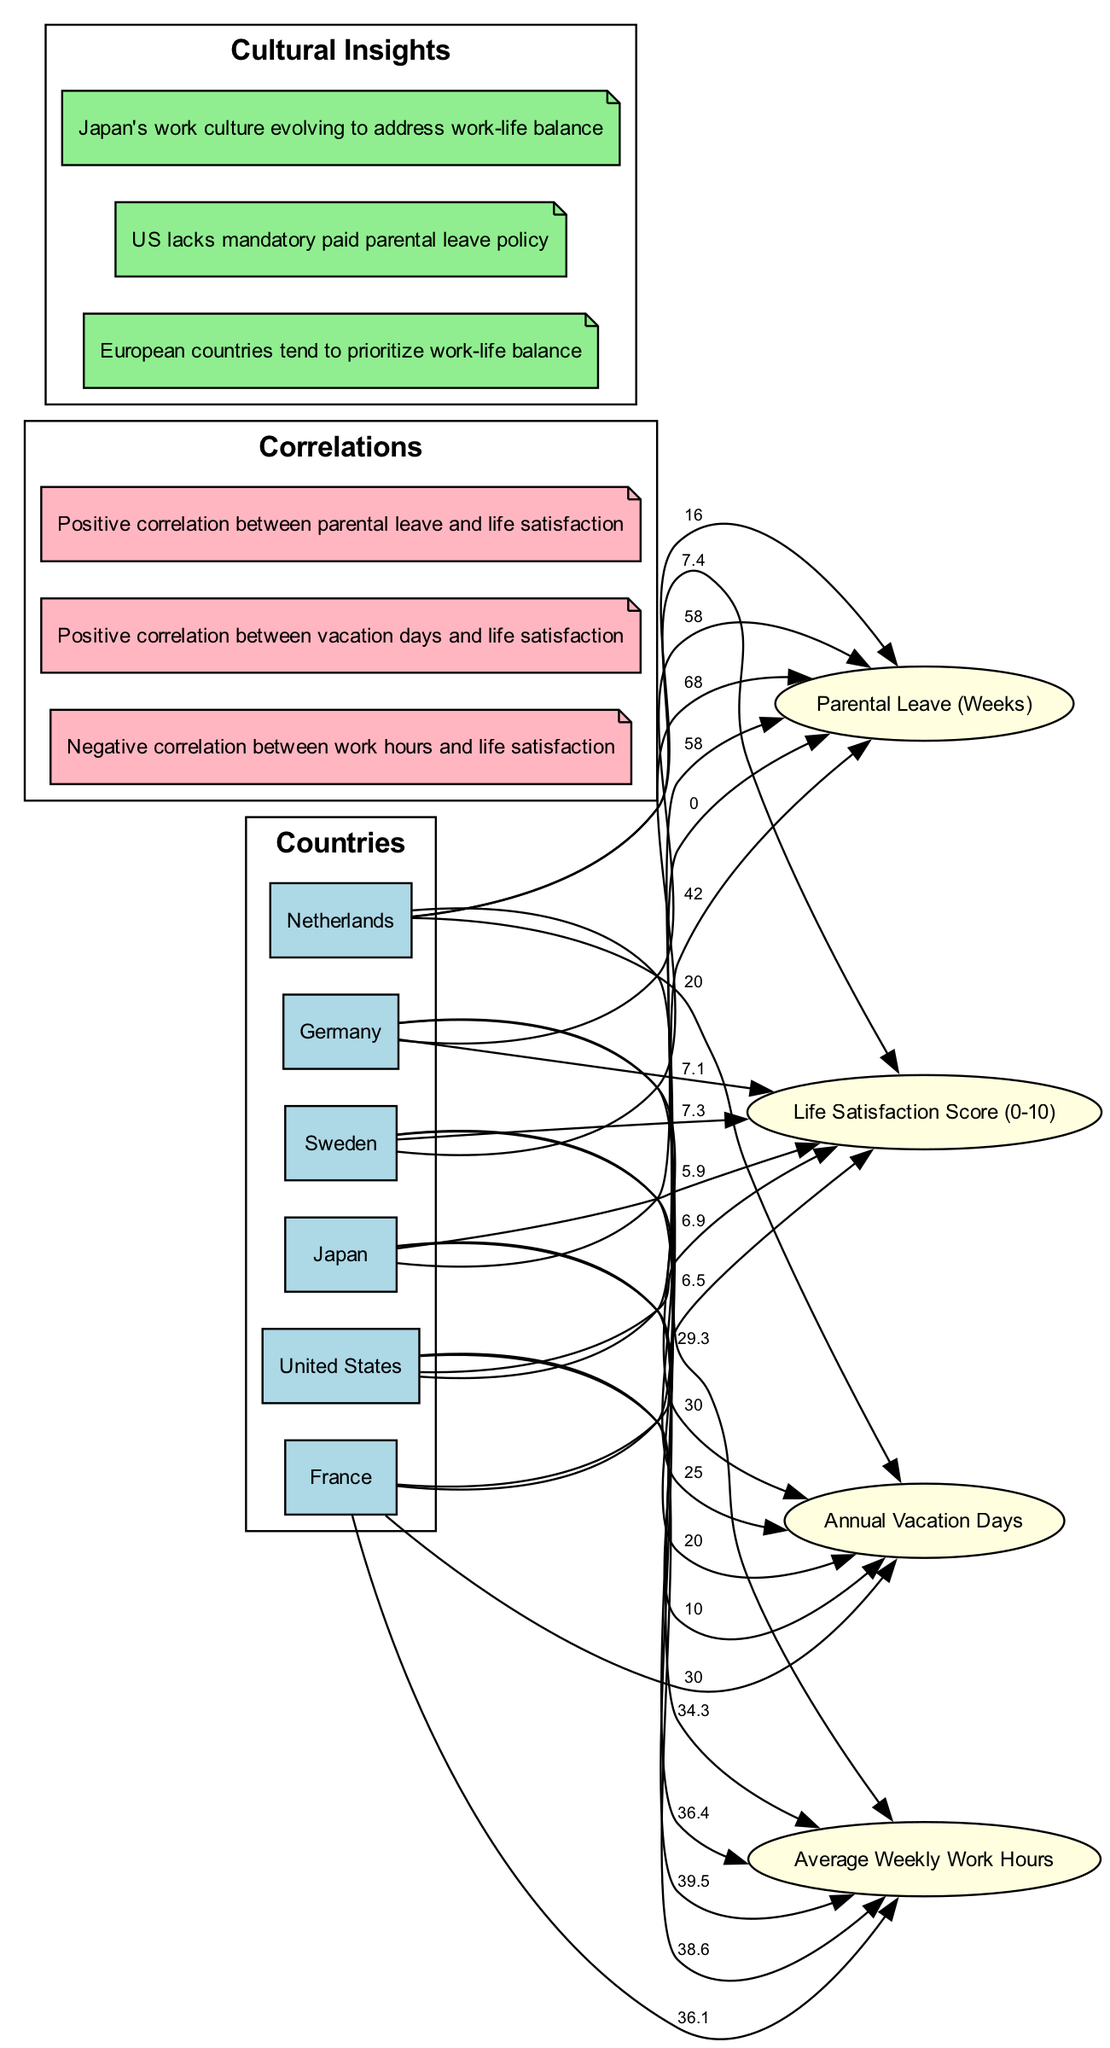What is the average weekly work hours in Germany? By locating Germany's node on the diagram, one can see the edge leading to the metric "Average Weekly Work Hours," which is labeled with the value of 34.3.
Answer: 34.3 How many annual vacation days does the United States provide? The edge connecting the United States to "Annual Vacation Days" shows a label with the value 10, indicating this is the amount of vacation days the country provides.
Answer: 10 What is the life satisfaction score for Japan? To find this, trace the line from Japan to "Life Satisfaction Score (0-10)," where the label displays the score as 5.9.
Answer: 5.9 Which country has the highest annual vacation days? Reviewing the vacation days labels from each country, it is evident that Germany and France each have 30 days, while Japan has 20, making Germany and France the highest.
Answer: Germany and France Is there a correlation between parental leave duration and life satisfaction? By examining the correlations section of the diagram, specifically the positive correlation between "Parental Leave (Weeks)" and "Life Satisfaction Score," it is clear that there is indeed a link between the two.
Answer: Yes Which country has the least average weekly work hours? Analyzing the average weekly work hours listed, the Netherlands has the lowest at 29.3, making it the country with the least hours in this metric.
Answer: Netherlands What is the correlation between vacation days and life satisfaction? The diagram states that there is a positive correlation between "Annual Vacation Days" and "Life Satisfaction Score," indicating that increases in vacation days may lead to higher life satisfaction.
Answer: Positive correlation How does parental leave in Sweden compare to that in France? Looking at the diagram, Sweden has 68 weeks of parental leave while France has 42 weeks, showing that Sweden offers significantly more parental leave.
Answer: More parental leave in Sweden Which country has no parental leave policy? By examining the parental leave metric's labels, it is clear that the United States is uniquely marked with a 0, indicating it lacks a formal parental leave policy.
Answer: United States 